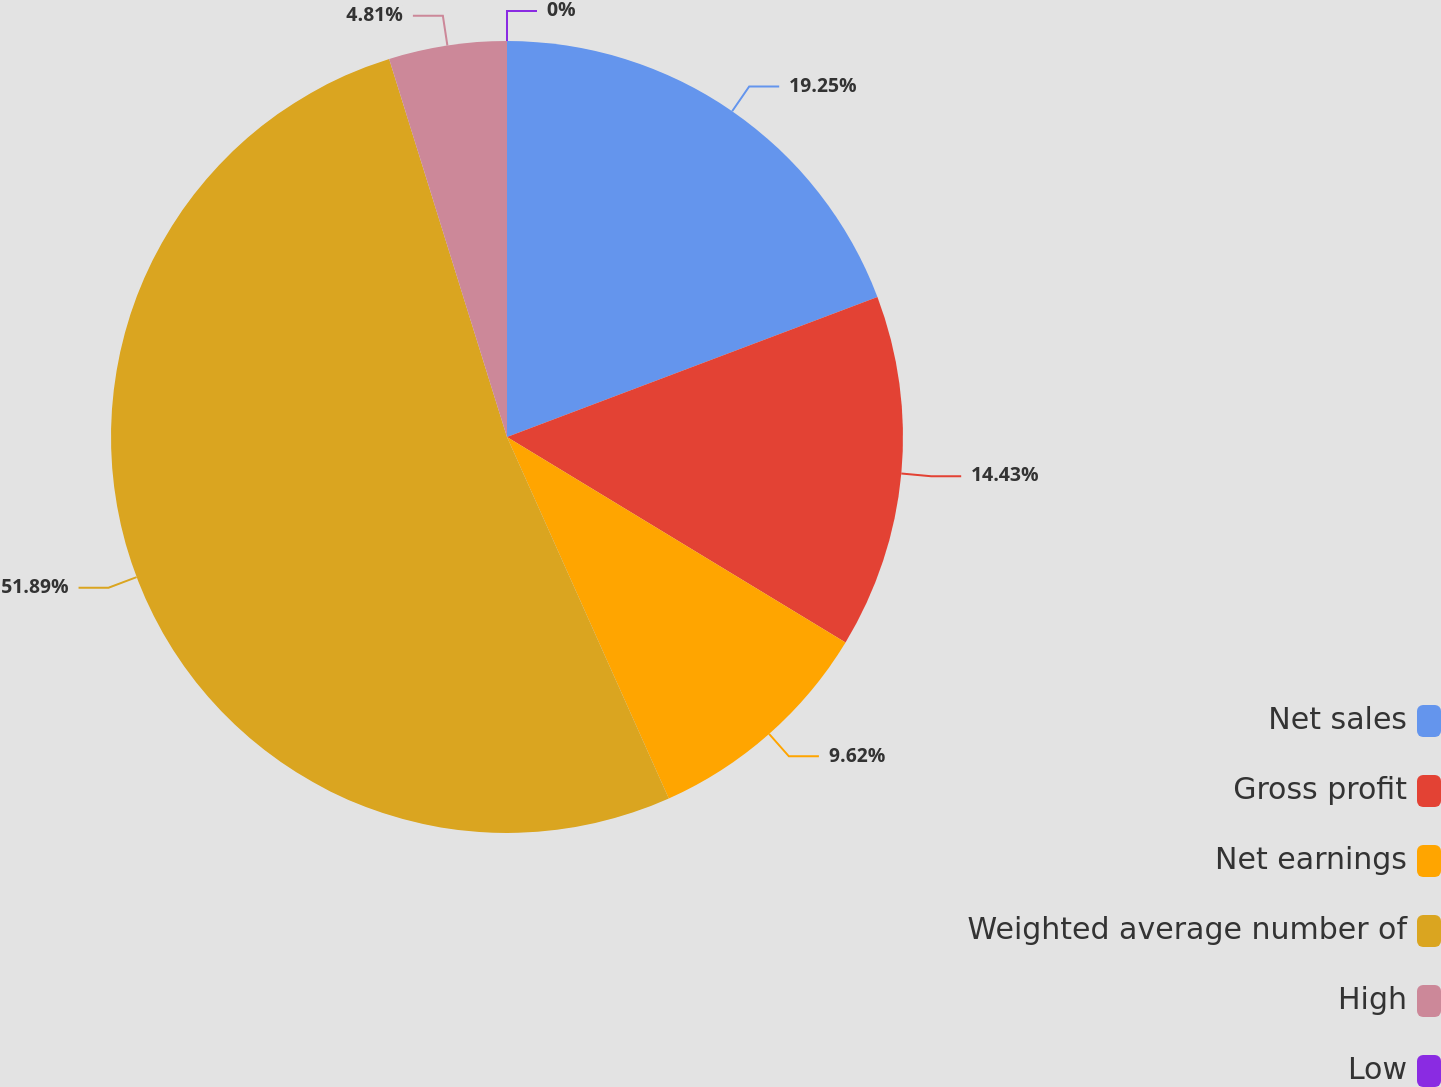Convert chart to OTSL. <chart><loc_0><loc_0><loc_500><loc_500><pie_chart><fcel>Net sales<fcel>Gross profit<fcel>Net earnings<fcel>Weighted average number of<fcel>High<fcel>Low<nl><fcel>19.25%<fcel>14.43%<fcel>9.62%<fcel>51.89%<fcel>4.81%<fcel>0.0%<nl></chart> 